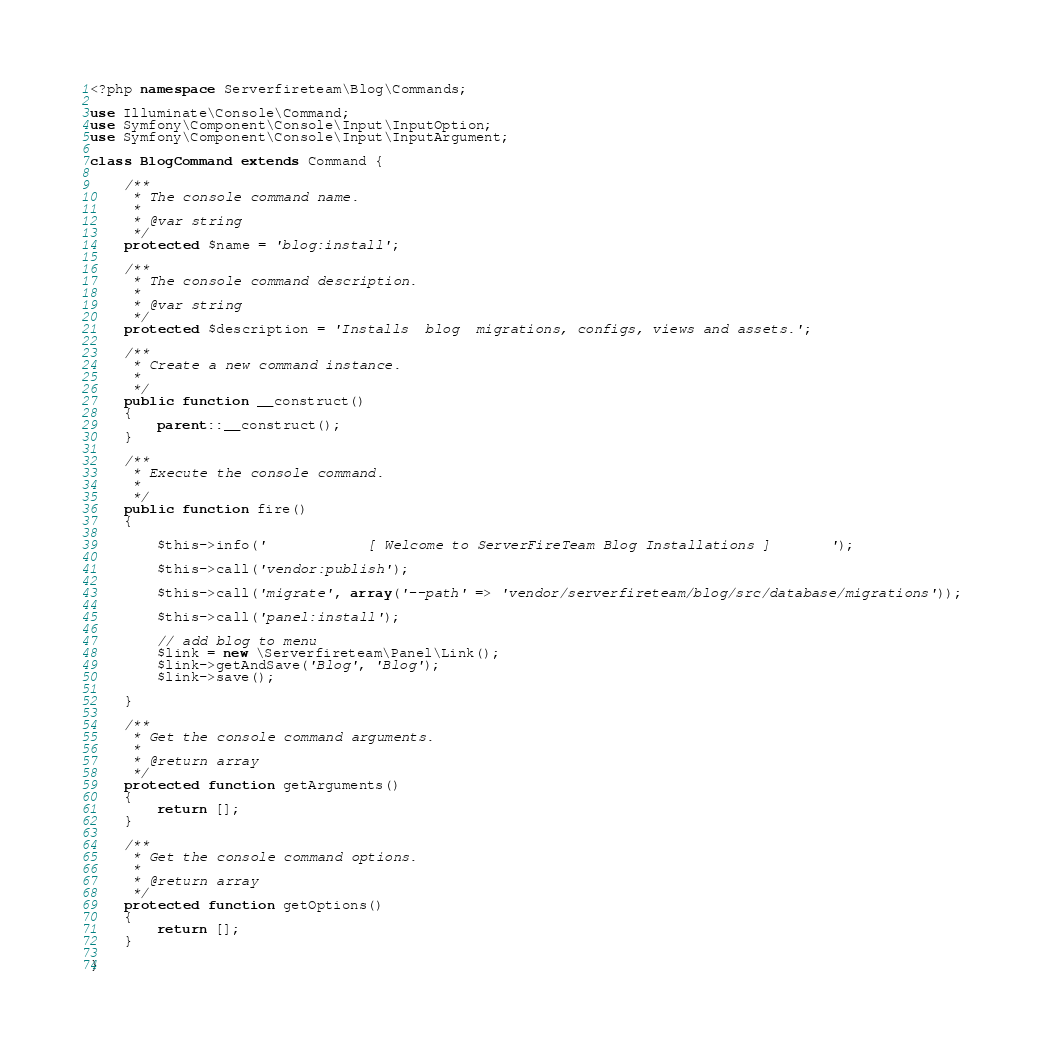<code> <loc_0><loc_0><loc_500><loc_500><_PHP_><?php namespace Serverfireteam\Blog\Commands;

use Illuminate\Console\Command;
use Symfony\Component\Console\Input\InputOption;
use Symfony\Component\Console\Input\InputArgument;

class BlogCommand extends Command {

	/**
	 * The console command name.
	 *
	 * @var string
	 */
	protected $name = 'blog:install';

	/**
	 * The console command description.
	 *
	 * @var string
	 */
	protected $description = 'Installs  blog  migrations, configs, views and assets.';

	/**
	 * Create a new command instance.
	 *
	 */
	public function __construct()
	{
		parent::__construct();
	}

	/**
	 * Execute the console command.
	 *
	 */
	public function fire()
	{
       
        $this->info('            [ Welcome to ServerFireTeam Blog Installations ]       ');
        
        $this->call('vendor:publish');
        
        $this->call('migrate', array('--path' => 'vendor/serverfireteam/blog/src/database/migrations'));

        $this->call('panel:install');

        // add blog to menu 
        $link = new \Serverfireteam\Panel\Link();
        $link->getAndSave('Blog', 'Blog');
        $link->save();
        
	}

	/**
	 * Get the console command arguments.
	 *
	 * @return array
	 */
	protected function getArguments()
	{
		return [];
	}

	/**
	 * Get the console command options.
	 *
	 * @return array
	 */
	protected function getOptions()
	{
		return [];
	}

}
</code> 